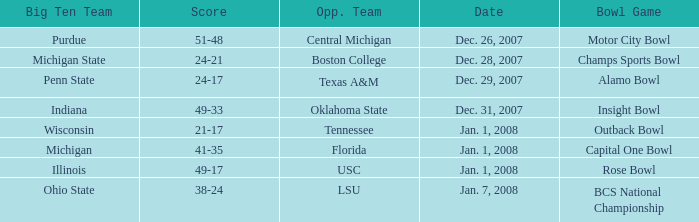What was the score of the Insight Bowl? 49-33. 